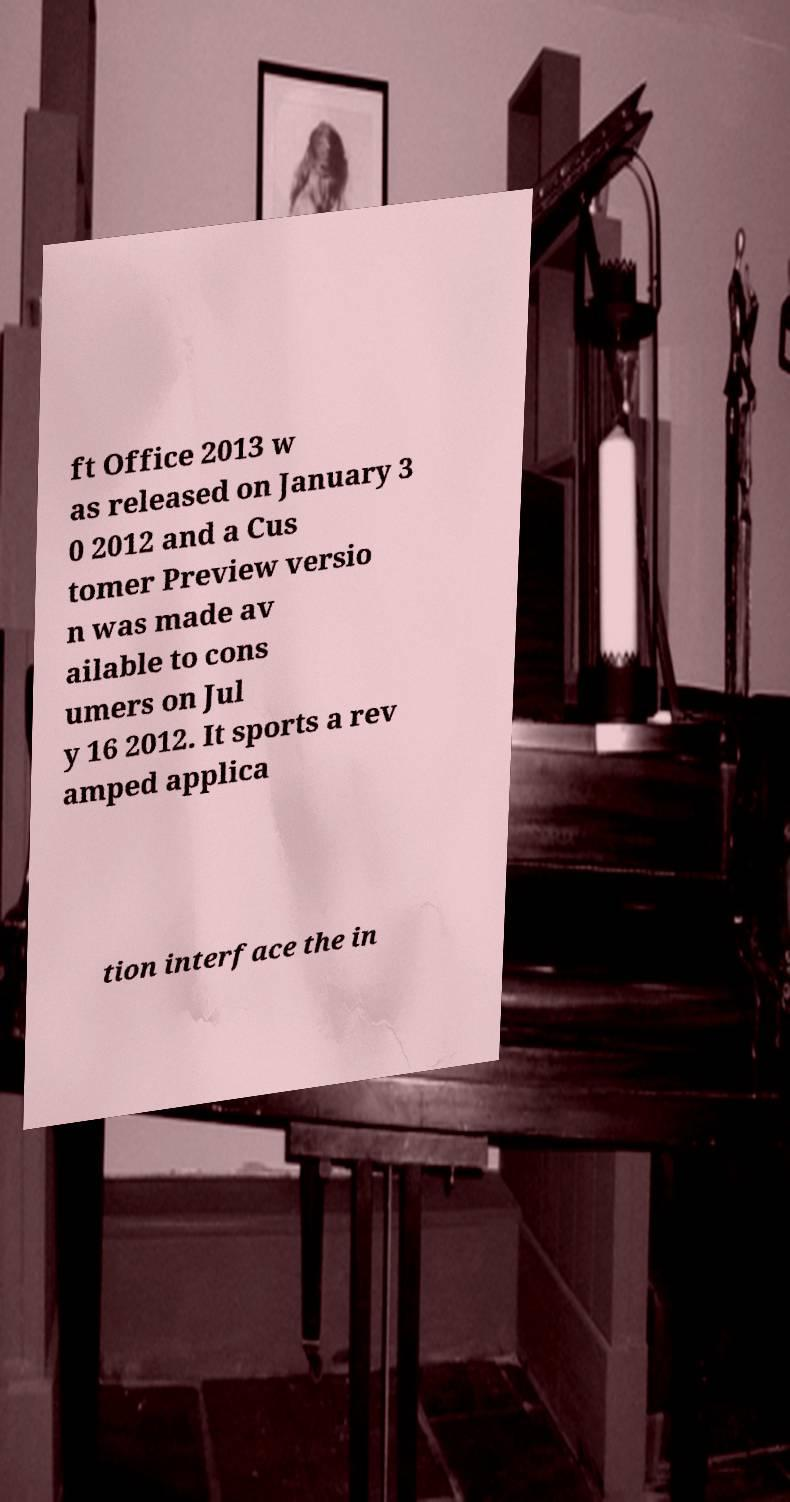Can you read and provide the text displayed in the image?This photo seems to have some interesting text. Can you extract and type it out for me? ft Office 2013 w as released on January 3 0 2012 and a Cus tomer Preview versio n was made av ailable to cons umers on Jul y 16 2012. It sports a rev amped applica tion interface the in 